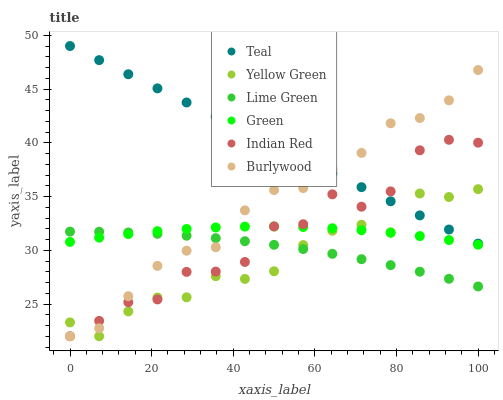Does Yellow Green have the minimum area under the curve?
Answer yes or no. Yes. Does Teal have the maximum area under the curve?
Answer yes or no. Yes. Does Burlywood have the minimum area under the curve?
Answer yes or no. No. Does Burlywood have the maximum area under the curve?
Answer yes or no. No. Is Teal the smoothest?
Answer yes or no. Yes. Is Indian Red the roughest?
Answer yes or no. Yes. Is Yellow Green the smoothest?
Answer yes or no. No. Is Yellow Green the roughest?
Answer yes or no. No. Does Yellow Green have the lowest value?
Answer yes or no. Yes. Does Green have the lowest value?
Answer yes or no. No. Does Teal have the highest value?
Answer yes or no. Yes. Does Yellow Green have the highest value?
Answer yes or no. No. Is Green less than Teal?
Answer yes or no. Yes. Is Teal greater than Green?
Answer yes or no. Yes. Does Yellow Green intersect Teal?
Answer yes or no. Yes. Is Yellow Green less than Teal?
Answer yes or no. No. Is Yellow Green greater than Teal?
Answer yes or no. No. Does Green intersect Teal?
Answer yes or no. No. 